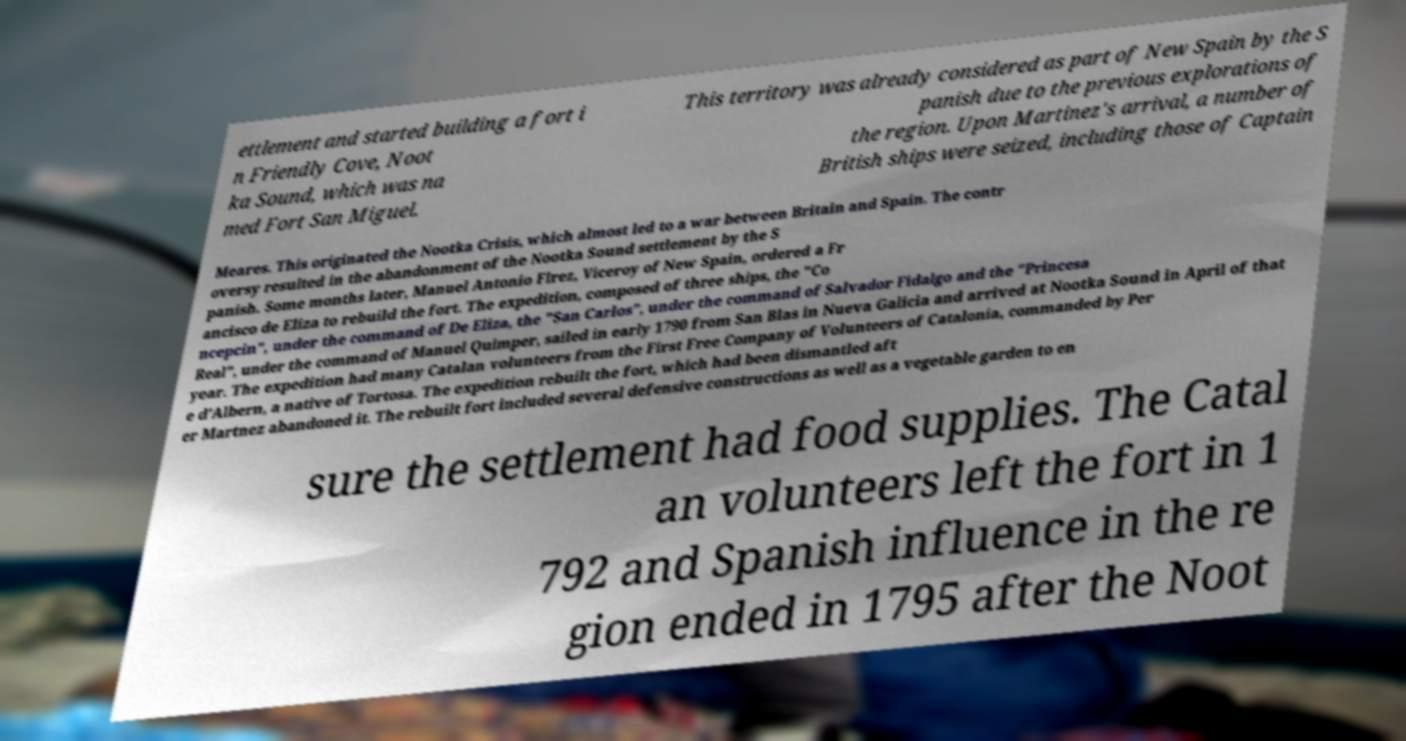Please identify and transcribe the text found in this image. ettlement and started building a fort i n Friendly Cove, Noot ka Sound, which was na med Fort San Miguel. This territory was already considered as part of New Spain by the S panish due to the previous explorations of the region. Upon Martinez's arrival, a number of British ships were seized, including those of Captain Meares. This originated the Nootka Crisis, which almost led to a war between Britain and Spain. The contr oversy resulted in the abandonment of the Nootka Sound settlement by the S panish. Some months later, Manuel Antonio Flrez, Viceroy of New Spain, ordered a Fr ancisco de Eliza to rebuild the fort. The expedition, composed of three ships, the "Co ncepcin", under the command of De Eliza, the "San Carlos", under the command of Salvador Fidalgo and the "Princesa Real", under the command of Manuel Quimper, sailed in early 1790 from San Blas in Nueva Galicia and arrived at Nootka Sound in April of that year. The expedition had many Catalan volunteers from the First Free Company of Volunteers of Catalonia, commanded by Per e d'Albern, a native of Tortosa. The expedition rebuilt the fort, which had been dismantled aft er Martnez abandoned it. The rebuilt fort included several defensive constructions as well as a vegetable garden to en sure the settlement had food supplies. The Catal an volunteers left the fort in 1 792 and Spanish influence in the re gion ended in 1795 after the Noot 